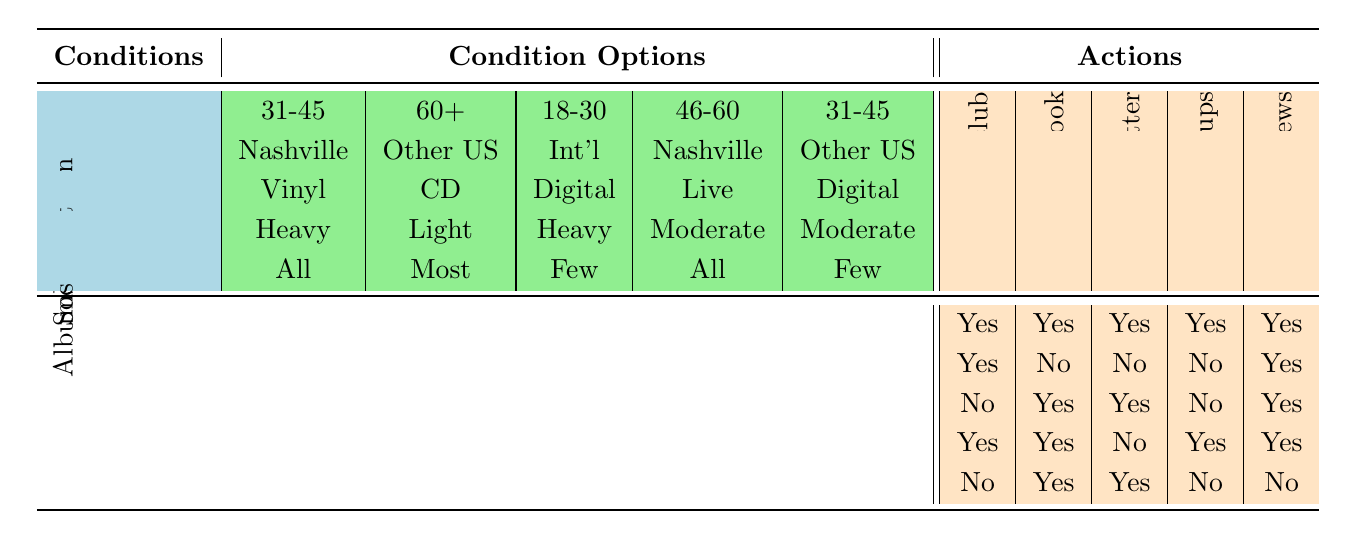What actions will someone aged 31-45 in the Nashville area, who prefers vinyl and owns all albums, likely take regarding the fan club? Looking at the row that matches the conditions: Age 31-45, Location Nashville, Preferred format Vinyl, and Album ownership All. The corresponding actions all show "Yes," indicating strong engagement with the fan club.
Answer: Yes for all actions Are there any conditions where someone who is 60+ and from Other US cities prefers CD and owns most albums? We see while examining the second rule, it fits perfectly with the stipulated conditions. The actions show "Yes" for joining the official fan club and subscribing to the newsletter, but not for other actions.
Answer: Yes How many actions does a person aged 46-60 in the Nashville area, who prefers live concerts and owns all albums, take? Looking at the row with Age 46-60, Location Nashville, Preferred format Live concerts, and Album ownership All, we see they answer "Yes" for joining the official fan club, joining the Facebook group, attending meetups, and subscribing to the newsletter, totaling 4 actions.
Answer: 4 If someone aged 18-30 prefers digital streaming, has few albums, and is an international resident, which two fan club actions will they likely take? We need to check the row that matches age 18-30, International location, Digital streaming format, and Few albums ownership. The actions specified here are "No" for joining the official fan club, "Yes" for joining the Facebook group, "Yes" for following on Twitter, "No" for attending meetups, and "Yes" for subscribing to the newsletter. The two actions they will likely take are joining the Facebook group and following on Twitter.
Answer: Join Facebook group, Follow on Twitter What is the result for someone who is 31-45 years old, lives in Other US cities, prefers digital streaming, has few albums, and how many total active commitments will they have? We look at the corresponding row, which describes this individual's traits. It states that the actions are "No" for joining the official fan club, "Yes" for joining the Facebook group, "Yes" for following on Twitter, "No" for attending meetups, and "No" for subscribing to the newsletter. Summing the "Yes" answers gives a total of 2 active commitments.
Answer: 2 